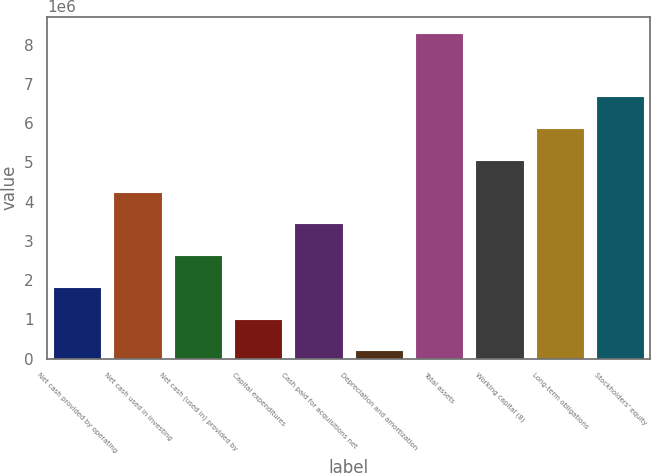Convert chart to OTSL. <chart><loc_0><loc_0><loc_500><loc_500><bar_chart><fcel>Net cash provided by operating<fcel>Net cash used in investing<fcel>Net cash (used in) provided by<fcel>Capital expenditures<fcel>Cash paid for acquisitions net<fcel>Depreciation and amortization<fcel>Total assets<fcel>Working capital (8)<fcel>Long-term obligations<fcel>Stockholders' equity<nl><fcel>1.82551e+06<fcel>4.25464e+06<fcel>2.63522e+06<fcel>1.0158e+06<fcel>3.44493e+06<fcel>206086<fcel>8.3032e+06<fcel>5.06435e+06<fcel>5.87407e+06<fcel>6.68378e+06<nl></chart> 